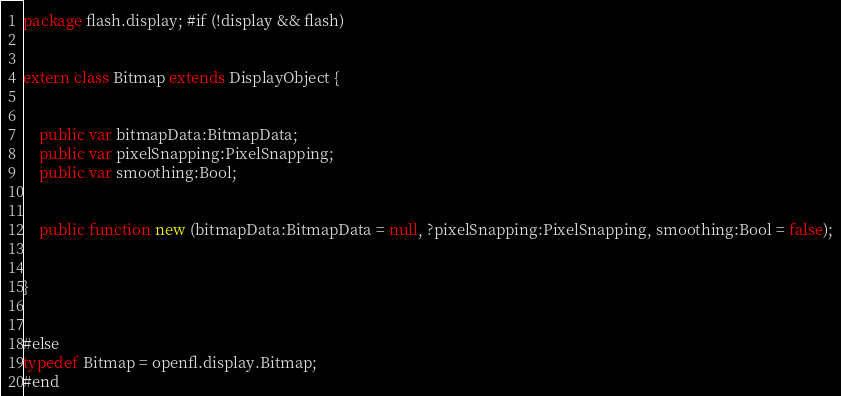Convert code to text. <code><loc_0><loc_0><loc_500><loc_500><_Haxe_>package flash.display; #if (!display && flash)


extern class Bitmap extends DisplayObject {
	
	
	public var bitmapData:BitmapData;
	public var pixelSnapping:PixelSnapping;
	public var smoothing:Bool;
	
	
	public function new (bitmapData:BitmapData = null, ?pixelSnapping:PixelSnapping, smoothing:Bool = false);
	
	
}


#else
typedef Bitmap = openfl.display.Bitmap;
#end</code> 